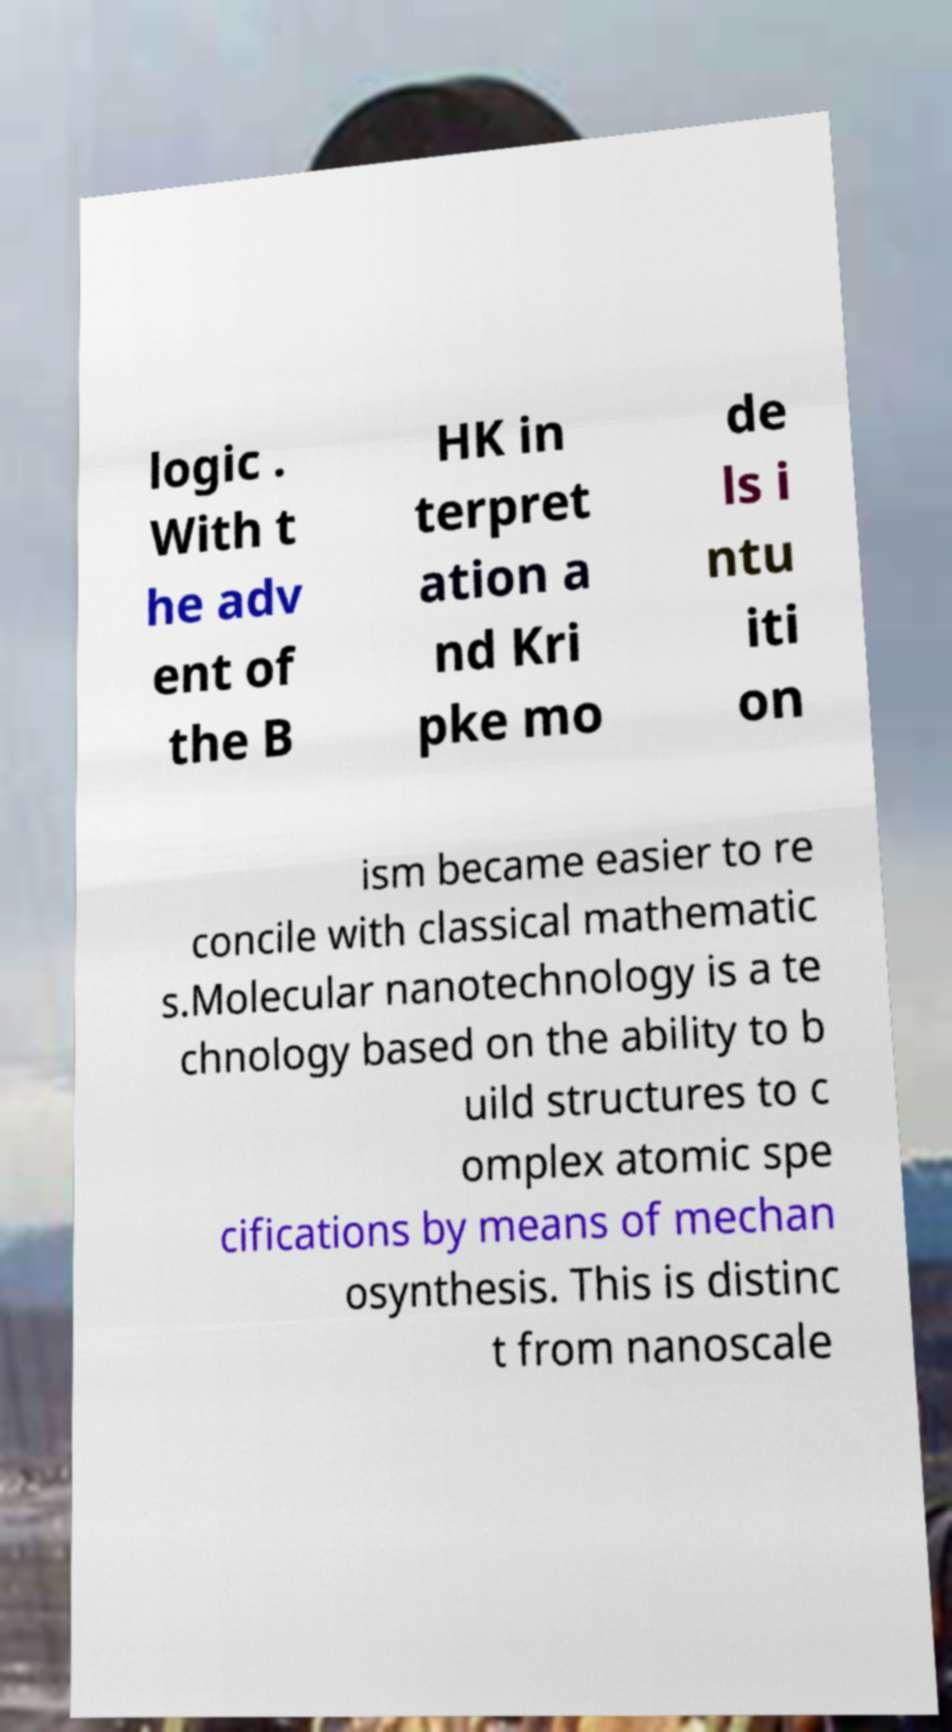There's text embedded in this image that I need extracted. Can you transcribe it verbatim? logic . With t he adv ent of the B HK in terpret ation a nd Kri pke mo de ls i ntu iti on ism became easier to re concile with classical mathematic s.Molecular nanotechnology is a te chnology based on the ability to b uild structures to c omplex atomic spe cifications by means of mechan osynthesis. This is distinc t from nanoscale 